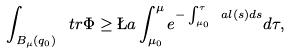<formula> <loc_0><loc_0><loc_500><loc_500>\int _ { B _ { \mu } ( q _ { 0 } ) } \ t r \Phi \geq \L a \int _ { \mu _ { 0 } } ^ { \mu } e ^ { - \int _ { \mu _ { 0 } } ^ { \tau } \ a l ( s ) d s } d \tau ,</formula> 